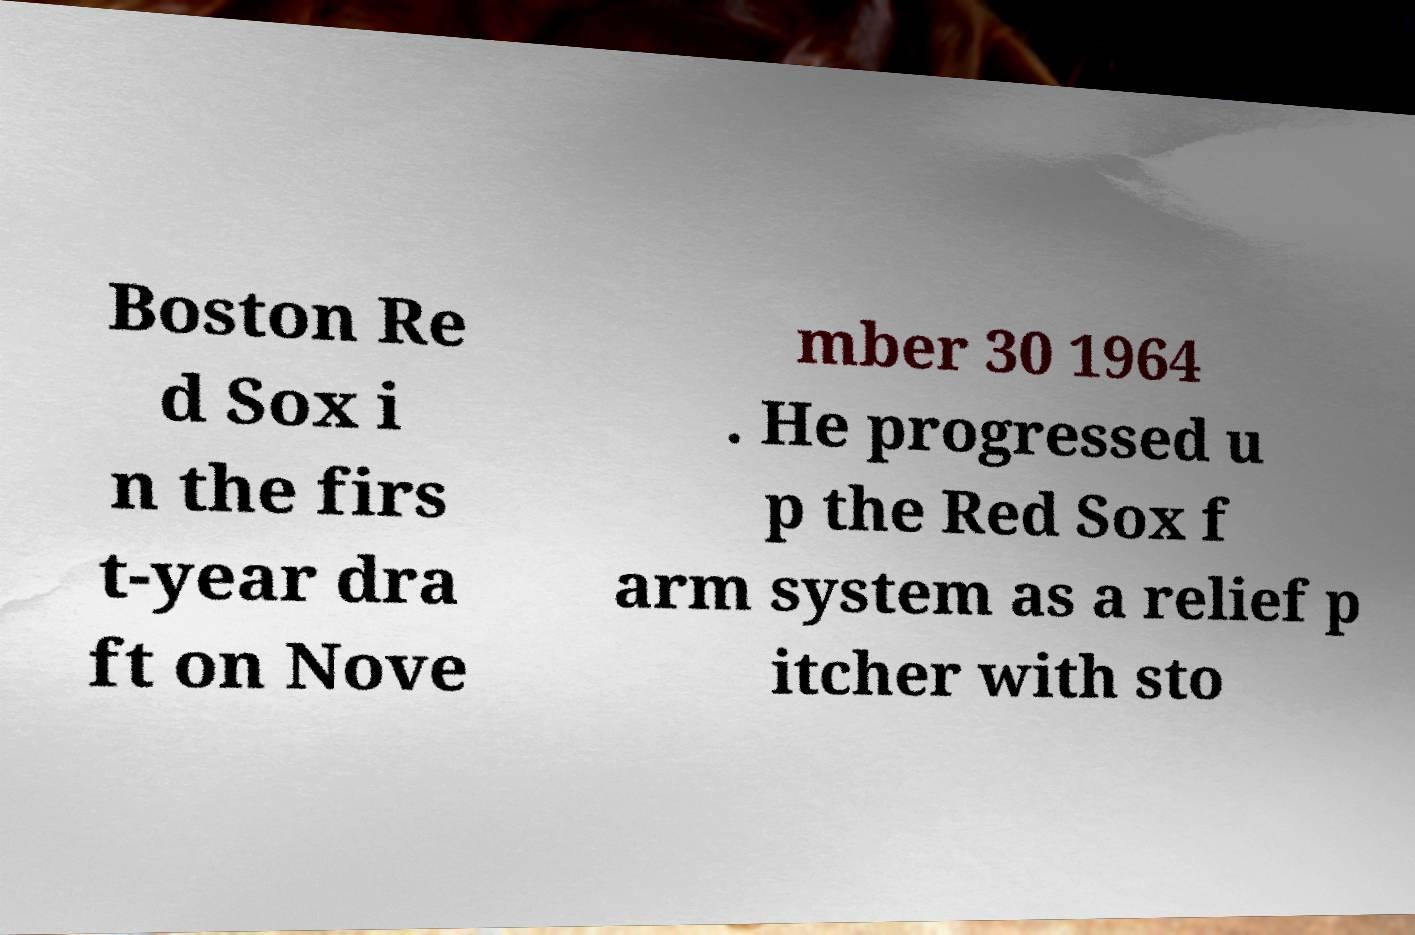Can you read and provide the text displayed in the image?This photo seems to have some interesting text. Can you extract and type it out for me? Boston Re d Sox i n the firs t-year dra ft on Nove mber 30 1964 . He progressed u p the Red Sox f arm system as a relief p itcher with sto 